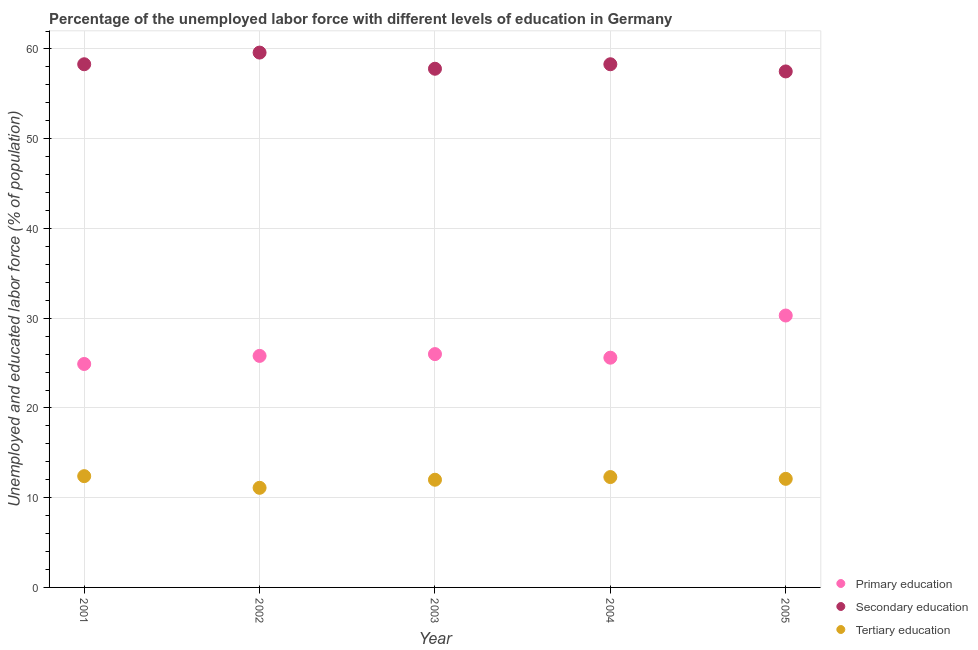How many different coloured dotlines are there?
Offer a terse response. 3. Is the number of dotlines equal to the number of legend labels?
Ensure brevity in your answer.  Yes. What is the percentage of labor force who received tertiary education in 2004?
Provide a succinct answer. 12.3. Across all years, what is the maximum percentage of labor force who received tertiary education?
Offer a very short reply. 12.4. Across all years, what is the minimum percentage of labor force who received secondary education?
Offer a terse response. 57.5. What is the total percentage of labor force who received tertiary education in the graph?
Give a very brief answer. 59.9. What is the difference between the percentage of labor force who received tertiary education in 2002 and that in 2004?
Provide a short and direct response. -1.2. What is the difference between the percentage of labor force who received primary education in 2001 and the percentage of labor force who received secondary education in 2002?
Make the answer very short. -34.7. What is the average percentage of labor force who received tertiary education per year?
Make the answer very short. 11.98. In the year 2005, what is the difference between the percentage of labor force who received tertiary education and percentage of labor force who received secondary education?
Your answer should be compact. -45.4. What is the ratio of the percentage of labor force who received tertiary education in 2002 to that in 2004?
Ensure brevity in your answer.  0.9. Is the percentage of labor force who received secondary education in 2002 less than that in 2005?
Provide a succinct answer. No. Is the difference between the percentage of labor force who received tertiary education in 2001 and 2002 greater than the difference between the percentage of labor force who received secondary education in 2001 and 2002?
Make the answer very short. Yes. What is the difference between the highest and the second highest percentage of labor force who received secondary education?
Make the answer very short. 1.3. What is the difference between the highest and the lowest percentage of labor force who received primary education?
Your answer should be compact. 5.4. In how many years, is the percentage of labor force who received primary education greater than the average percentage of labor force who received primary education taken over all years?
Provide a succinct answer. 1. Is the sum of the percentage of labor force who received primary education in 2001 and 2002 greater than the maximum percentage of labor force who received tertiary education across all years?
Provide a succinct answer. Yes. Is it the case that in every year, the sum of the percentage of labor force who received primary education and percentage of labor force who received secondary education is greater than the percentage of labor force who received tertiary education?
Ensure brevity in your answer.  Yes. Does the percentage of labor force who received tertiary education monotonically increase over the years?
Offer a terse response. No. Is the percentage of labor force who received secondary education strictly greater than the percentage of labor force who received primary education over the years?
Give a very brief answer. Yes. What is the difference between two consecutive major ticks on the Y-axis?
Provide a short and direct response. 10. Are the values on the major ticks of Y-axis written in scientific E-notation?
Offer a terse response. No. Does the graph contain any zero values?
Give a very brief answer. No. Does the graph contain grids?
Offer a terse response. Yes. Where does the legend appear in the graph?
Give a very brief answer. Bottom right. How many legend labels are there?
Provide a short and direct response. 3. How are the legend labels stacked?
Your answer should be very brief. Vertical. What is the title of the graph?
Your response must be concise. Percentage of the unemployed labor force with different levels of education in Germany. What is the label or title of the X-axis?
Keep it short and to the point. Year. What is the label or title of the Y-axis?
Your answer should be compact. Unemployed and educated labor force (% of population). What is the Unemployed and educated labor force (% of population) of Primary education in 2001?
Offer a terse response. 24.9. What is the Unemployed and educated labor force (% of population) of Secondary education in 2001?
Provide a succinct answer. 58.3. What is the Unemployed and educated labor force (% of population) of Tertiary education in 2001?
Offer a terse response. 12.4. What is the Unemployed and educated labor force (% of population) of Primary education in 2002?
Your answer should be very brief. 25.8. What is the Unemployed and educated labor force (% of population) of Secondary education in 2002?
Offer a terse response. 59.6. What is the Unemployed and educated labor force (% of population) of Tertiary education in 2002?
Your answer should be compact. 11.1. What is the Unemployed and educated labor force (% of population) in Secondary education in 2003?
Offer a very short reply. 57.8. What is the Unemployed and educated labor force (% of population) in Tertiary education in 2003?
Offer a terse response. 12. What is the Unemployed and educated labor force (% of population) of Primary education in 2004?
Provide a short and direct response. 25.6. What is the Unemployed and educated labor force (% of population) of Secondary education in 2004?
Keep it short and to the point. 58.3. What is the Unemployed and educated labor force (% of population) in Tertiary education in 2004?
Provide a succinct answer. 12.3. What is the Unemployed and educated labor force (% of population) of Primary education in 2005?
Offer a very short reply. 30.3. What is the Unemployed and educated labor force (% of population) of Secondary education in 2005?
Your response must be concise. 57.5. What is the Unemployed and educated labor force (% of population) of Tertiary education in 2005?
Keep it short and to the point. 12.1. Across all years, what is the maximum Unemployed and educated labor force (% of population) in Primary education?
Your answer should be compact. 30.3. Across all years, what is the maximum Unemployed and educated labor force (% of population) in Secondary education?
Keep it short and to the point. 59.6. Across all years, what is the maximum Unemployed and educated labor force (% of population) of Tertiary education?
Keep it short and to the point. 12.4. Across all years, what is the minimum Unemployed and educated labor force (% of population) of Primary education?
Your answer should be compact. 24.9. Across all years, what is the minimum Unemployed and educated labor force (% of population) of Secondary education?
Your response must be concise. 57.5. Across all years, what is the minimum Unemployed and educated labor force (% of population) in Tertiary education?
Your answer should be compact. 11.1. What is the total Unemployed and educated labor force (% of population) of Primary education in the graph?
Give a very brief answer. 132.6. What is the total Unemployed and educated labor force (% of population) of Secondary education in the graph?
Your answer should be compact. 291.5. What is the total Unemployed and educated labor force (% of population) of Tertiary education in the graph?
Your response must be concise. 59.9. What is the difference between the Unemployed and educated labor force (% of population) of Primary education in 2001 and that in 2003?
Your response must be concise. -1.1. What is the difference between the Unemployed and educated labor force (% of population) of Tertiary education in 2001 and that in 2003?
Make the answer very short. 0.4. What is the difference between the Unemployed and educated labor force (% of population) in Tertiary education in 2001 and that in 2004?
Offer a very short reply. 0.1. What is the difference between the Unemployed and educated labor force (% of population) in Tertiary education in 2002 and that in 2003?
Provide a succinct answer. -0.9. What is the difference between the Unemployed and educated labor force (% of population) in Tertiary education in 2002 and that in 2004?
Your answer should be very brief. -1.2. What is the difference between the Unemployed and educated labor force (% of population) in Primary education in 2003 and that in 2005?
Offer a very short reply. -4.3. What is the difference between the Unemployed and educated labor force (% of population) of Tertiary education in 2003 and that in 2005?
Provide a short and direct response. -0.1. What is the difference between the Unemployed and educated labor force (% of population) of Primary education in 2004 and that in 2005?
Offer a terse response. -4.7. What is the difference between the Unemployed and educated labor force (% of population) in Secondary education in 2004 and that in 2005?
Keep it short and to the point. 0.8. What is the difference between the Unemployed and educated labor force (% of population) in Primary education in 2001 and the Unemployed and educated labor force (% of population) in Secondary education in 2002?
Your answer should be compact. -34.7. What is the difference between the Unemployed and educated labor force (% of population) of Primary education in 2001 and the Unemployed and educated labor force (% of population) of Tertiary education in 2002?
Provide a short and direct response. 13.8. What is the difference between the Unemployed and educated labor force (% of population) of Secondary education in 2001 and the Unemployed and educated labor force (% of population) of Tertiary education in 2002?
Ensure brevity in your answer.  47.2. What is the difference between the Unemployed and educated labor force (% of population) of Primary education in 2001 and the Unemployed and educated labor force (% of population) of Secondary education in 2003?
Your response must be concise. -32.9. What is the difference between the Unemployed and educated labor force (% of population) of Primary education in 2001 and the Unemployed and educated labor force (% of population) of Tertiary education in 2003?
Your answer should be compact. 12.9. What is the difference between the Unemployed and educated labor force (% of population) of Secondary education in 2001 and the Unemployed and educated labor force (% of population) of Tertiary education in 2003?
Provide a succinct answer. 46.3. What is the difference between the Unemployed and educated labor force (% of population) of Primary education in 2001 and the Unemployed and educated labor force (% of population) of Secondary education in 2004?
Keep it short and to the point. -33.4. What is the difference between the Unemployed and educated labor force (% of population) in Secondary education in 2001 and the Unemployed and educated labor force (% of population) in Tertiary education in 2004?
Your answer should be very brief. 46. What is the difference between the Unemployed and educated labor force (% of population) of Primary education in 2001 and the Unemployed and educated labor force (% of population) of Secondary education in 2005?
Your response must be concise. -32.6. What is the difference between the Unemployed and educated labor force (% of population) of Primary education in 2001 and the Unemployed and educated labor force (% of population) of Tertiary education in 2005?
Offer a terse response. 12.8. What is the difference between the Unemployed and educated labor force (% of population) in Secondary education in 2001 and the Unemployed and educated labor force (% of population) in Tertiary education in 2005?
Your response must be concise. 46.2. What is the difference between the Unemployed and educated labor force (% of population) of Primary education in 2002 and the Unemployed and educated labor force (% of population) of Secondary education in 2003?
Give a very brief answer. -32. What is the difference between the Unemployed and educated labor force (% of population) of Secondary education in 2002 and the Unemployed and educated labor force (% of population) of Tertiary education in 2003?
Your response must be concise. 47.6. What is the difference between the Unemployed and educated labor force (% of population) in Primary education in 2002 and the Unemployed and educated labor force (% of population) in Secondary education in 2004?
Your answer should be compact. -32.5. What is the difference between the Unemployed and educated labor force (% of population) in Secondary education in 2002 and the Unemployed and educated labor force (% of population) in Tertiary education in 2004?
Offer a very short reply. 47.3. What is the difference between the Unemployed and educated labor force (% of population) in Primary education in 2002 and the Unemployed and educated labor force (% of population) in Secondary education in 2005?
Your answer should be compact. -31.7. What is the difference between the Unemployed and educated labor force (% of population) in Primary education in 2002 and the Unemployed and educated labor force (% of population) in Tertiary education in 2005?
Your answer should be very brief. 13.7. What is the difference between the Unemployed and educated labor force (% of population) of Secondary education in 2002 and the Unemployed and educated labor force (% of population) of Tertiary education in 2005?
Offer a terse response. 47.5. What is the difference between the Unemployed and educated labor force (% of population) of Primary education in 2003 and the Unemployed and educated labor force (% of population) of Secondary education in 2004?
Your answer should be very brief. -32.3. What is the difference between the Unemployed and educated labor force (% of population) of Secondary education in 2003 and the Unemployed and educated labor force (% of population) of Tertiary education in 2004?
Provide a short and direct response. 45.5. What is the difference between the Unemployed and educated labor force (% of population) of Primary education in 2003 and the Unemployed and educated labor force (% of population) of Secondary education in 2005?
Give a very brief answer. -31.5. What is the difference between the Unemployed and educated labor force (% of population) in Secondary education in 2003 and the Unemployed and educated labor force (% of population) in Tertiary education in 2005?
Offer a very short reply. 45.7. What is the difference between the Unemployed and educated labor force (% of population) of Primary education in 2004 and the Unemployed and educated labor force (% of population) of Secondary education in 2005?
Your answer should be very brief. -31.9. What is the difference between the Unemployed and educated labor force (% of population) of Primary education in 2004 and the Unemployed and educated labor force (% of population) of Tertiary education in 2005?
Provide a succinct answer. 13.5. What is the difference between the Unemployed and educated labor force (% of population) of Secondary education in 2004 and the Unemployed and educated labor force (% of population) of Tertiary education in 2005?
Make the answer very short. 46.2. What is the average Unemployed and educated labor force (% of population) in Primary education per year?
Ensure brevity in your answer.  26.52. What is the average Unemployed and educated labor force (% of population) of Secondary education per year?
Ensure brevity in your answer.  58.3. What is the average Unemployed and educated labor force (% of population) of Tertiary education per year?
Keep it short and to the point. 11.98. In the year 2001, what is the difference between the Unemployed and educated labor force (% of population) in Primary education and Unemployed and educated labor force (% of population) in Secondary education?
Your response must be concise. -33.4. In the year 2001, what is the difference between the Unemployed and educated labor force (% of population) of Secondary education and Unemployed and educated labor force (% of population) of Tertiary education?
Make the answer very short. 45.9. In the year 2002, what is the difference between the Unemployed and educated labor force (% of population) in Primary education and Unemployed and educated labor force (% of population) in Secondary education?
Your answer should be compact. -33.8. In the year 2002, what is the difference between the Unemployed and educated labor force (% of population) of Secondary education and Unemployed and educated labor force (% of population) of Tertiary education?
Your answer should be very brief. 48.5. In the year 2003, what is the difference between the Unemployed and educated labor force (% of population) in Primary education and Unemployed and educated labor force (% of population) in Secondary education?
Offer a very short reply. -31.8. In the year 2003, what is the difference between the Unemployed and educated labor force (% of population) of Primary education and Unemployed and educated labor force (% of population) of Tertiary education?
Give a very brief answer. 14. In the year 2003, what is the difference between the Unemployed and educated labor force (% of population) in Secondary education and Unemployed and educated labor force (% of population) in Tertiary education?
Your answer should be very brief. 45.8. In the year 2004, what is the difference between the Unemployed and educated labor force (% of population) of Primary education and Unemployed and educated labor force (% of population) of Secondary education?
Provide a succinct answer. -32.7. In the year 2004, what is the difference between the Unemployed and educated labor force (% of population) in Secondary education and Unemployed and educated labor force (% of population) in Tertiary education?
Offer a terse response. 46. In the year 2005, what is the difference between the Unemployed and educated labor force (% of population) of Primary education and Unemployed and educated labor force (% of population) of Secondary education?
Ensure brevity in your answer.  -27.2. In the year 2005, what is the difference between the Unemployed and educated labor force (% of population) of Primary education and Unemployed and educated labor force (% of population) of Tertiary education?
Your answer should be very brief. 18.2. In the year 2005, what is the difference between the Unemployed and educated labor force (% of population) of Secondary education and Unemployed and educated labor force (% of population) of Tertiary education?
Make the answer very short. 45.4. What is the ratio of the Unemployed and educated labor force (% of population) in Primary education in 2001 to that in 2002?
Your answer should be very brief. 0.97. What is the ratio of the Unemployed and educated labor force (% of population) in Secondary education in 2001 to that in 2002?
Your answer should be very brief. 0.98. What is the ratio of the Unemployed and educated labor force (% of population) of Tertiary education in 2001 to that in 2002?
Your answer should be compact. 1.12. What is the ratio of the Unemployed and educated labor force (% of population) of Primary education in 2001 to that in 2003?
Provide a short and direct response. 0.96. What is the ratio of the Unemployed and educated labor force (% of population) of Secondary education in 2001 to that in 2003?
Keep it short and to the point. 1.01. What is the ratio of the Unemployed and educated labor force (% of population) in Tertiary education in 2001 to that in 2003?
Make the answer very short. 1.03. What is the ratio of the Unemployed and educated labor force (% of population) of Primary education in 2001 to that in 2004?
Provide a short and direct response. 0.97. What is the ratio of the Unemployed and educated labor force (% of population) in Tertiary education in 2001 to that in 2004?
Your response must be concise. 1.01. What is the ratio of the Unemployed and educated labor force (% of population) in Primary education in 2001 to that in 2005?
Offer a very short reply. 0.82. What is the ratio of the Unemployed and educated labor force (% of population) in Secondary education in 2001 to that in 2005?
Your answer should be compact. 1.01. What is the ratio of the Unemployed and educated labor force (% of population) in Tertiary education in 2001 to that in 2005?
Your response must be concise. 1.02. What is the ratio of the Unemployed and educated labor force (% of population) in Secondary education in 2002 to that in 2003?
Keep it short and to the point. 1.03. What is the ratio of the Unemployed and educated labor force (% of population) in Tertiary education in 2002 to that in 2003?
Offer a terse response. 0.93. What is the ratio of the Unemployed and educated labor force (% of population) in Secondary education in 2002 to that in 2004?
Give a very brief answer. 1.02. What is the ratio of the Unemployed and educated labor force (% of population) in Tertiary education in 2002 to that in 2004?
Make the answer very short. 0.9. What is the ratio of the Unemployed and educated labor force (% of population) in Primary education in 2002 to that in 2005?
Make the answer very short. 0.85. What is the ratio of the Unemployed and educated labor force (% of population) in Secondary education in 2002 to that in 2005?
Offer a terse response. 1.04. What is the ratio of the Unemployed and educated labor force (% of population) of Tertiary education in 2002 to that in 2005?
Keep it short and to the point. 0.92. What is the ratio of the Unemployed and educated labor force (% of population) of Primary education in 2003 to that in 2004?
Keep it short and to the point. 1.02. What is the ratio of the Unemployed and educated labor force (% of population) in Tertiary education in 2003 to that in 2004?
Provide a short and direct response. 0.98. What is the ratio of the Unemployed and educated labor force (% of population) of Primary education in 2003 to that in 2005?
Give a very brief answer. 0.86. What is the ratio of the Unemployed and educated labor force (% of population) in Secondary education in 2003 to that in 2005?
Ensure brevity in your answer.  1.01. What is the ratio of the Unemployed and educated labor force (% of population) of Primary education in 2004 to that in 2005?
Provide a succinct answer. 0.84. What is the ratio of the Unemployed and educated labor force (% of population) in Secondary education in 2004 to that in 2005?
Give a very brief answer. 1.01. What is the ratio of the Unemployed and educated labor force (% of population) in Tertiary education in 2004 to that in 2005?
Your answer should be compact. 1.02. What is the difference between the highest and the second highest Unemployed and educated labor force (% of population) in Primary education?
Provide a succinct answer. 4.3. What is the difference between the highest and the second highest Unemployed and educated labor force (% of population) in Tertiary education?
Offer a terse response. 0.1. What is the difference between the highest and the lowest Unemployed and educated labor force (% of population) in Secondary education?
Provide a succinct answer. 2.1. 